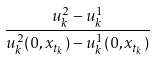<formula> <loc_0><loc_0><loc_500><loc_500>\frac { u ^ { 2 } _ { k } - u ^ { 1 } _ { k } } { u ^ { 2 } _ { k } ( 0 , x _ { t _ { k } } ) - u ^ { 1 } _ { k } ( 0 , x _ { t _ { k } } ) }</formula> 